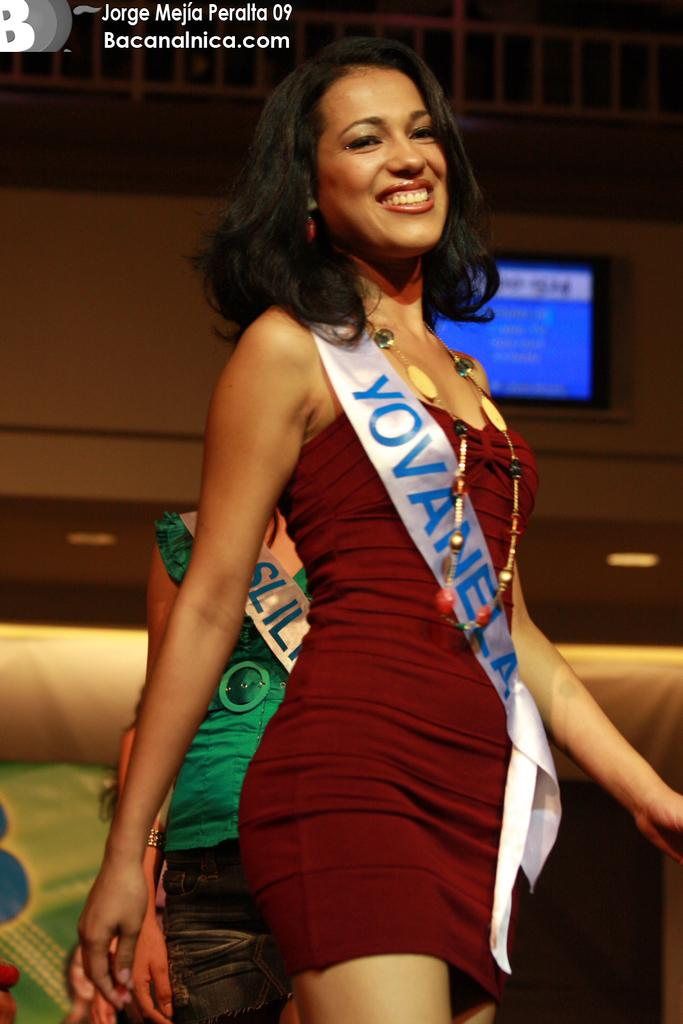Provide a one-sentence caption for the provided image. A contestant in a short, dark red dress, wears a sash saying, "YOVANELA". 